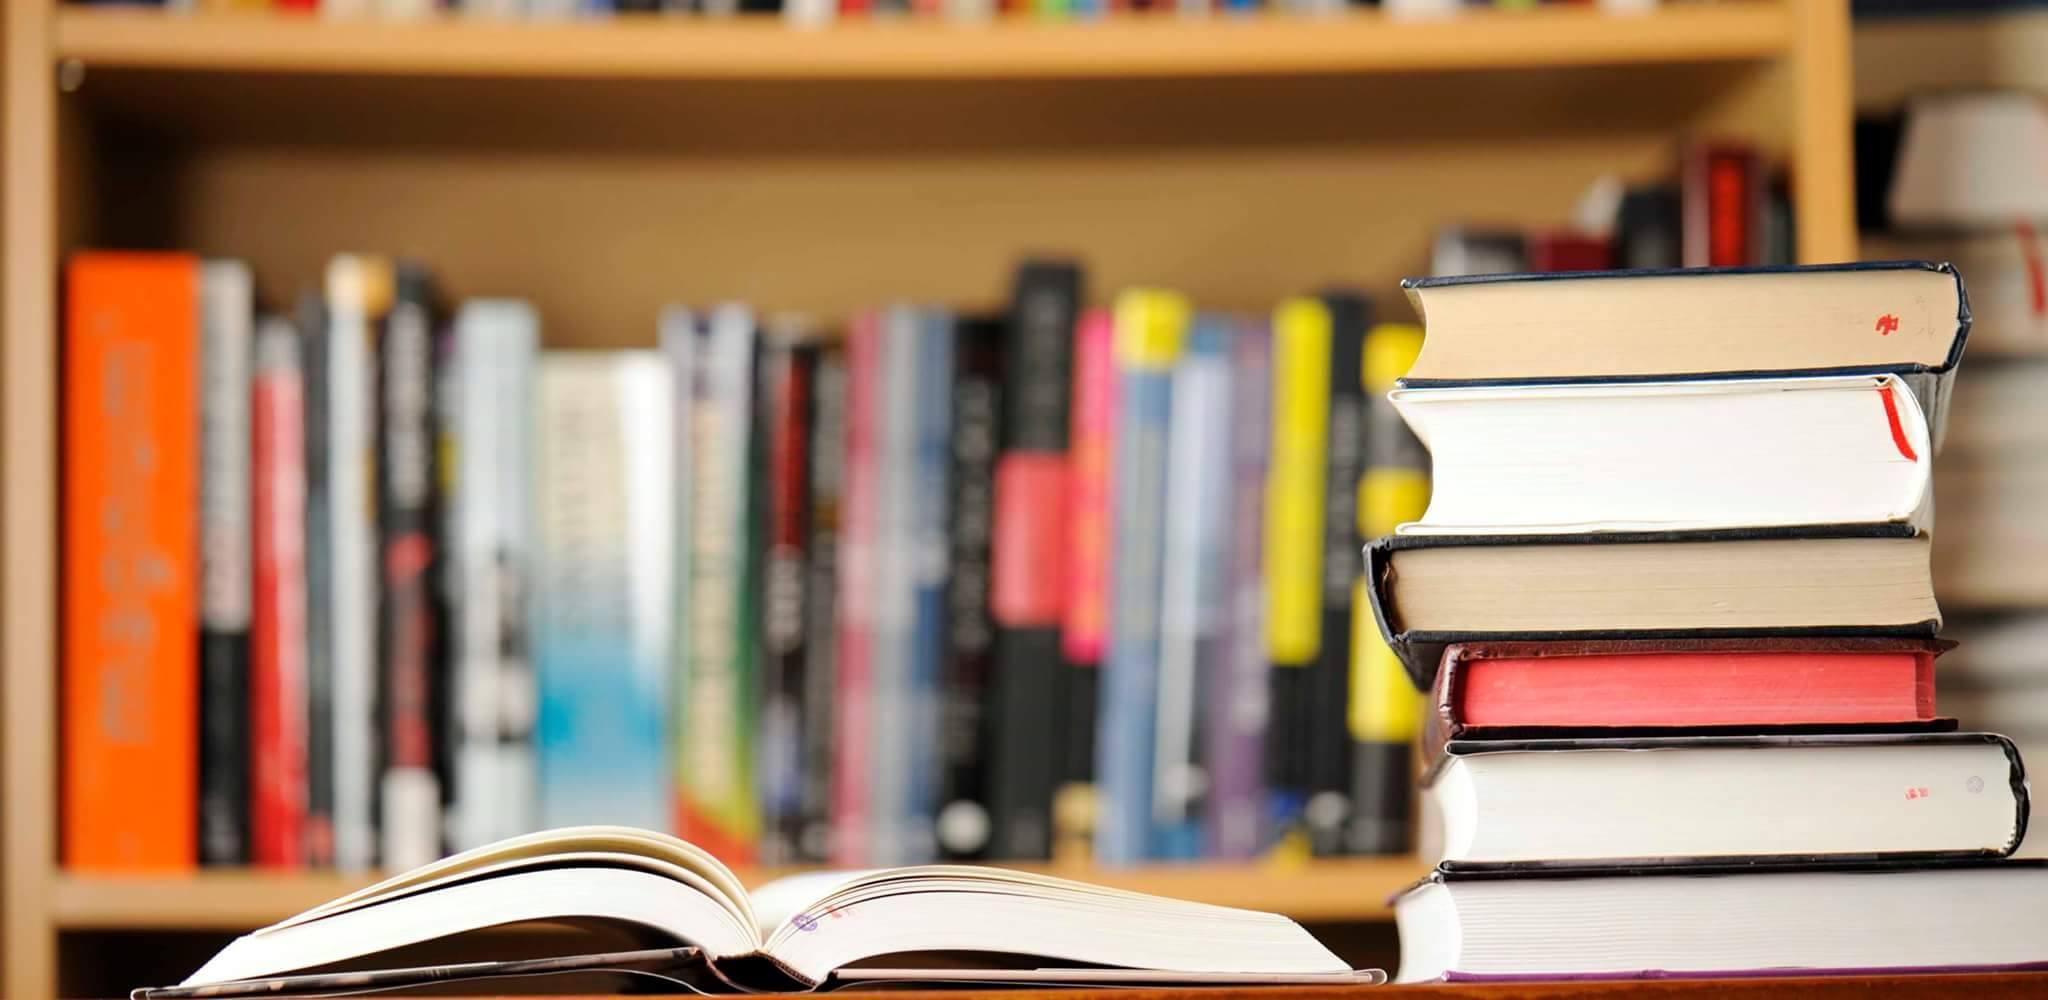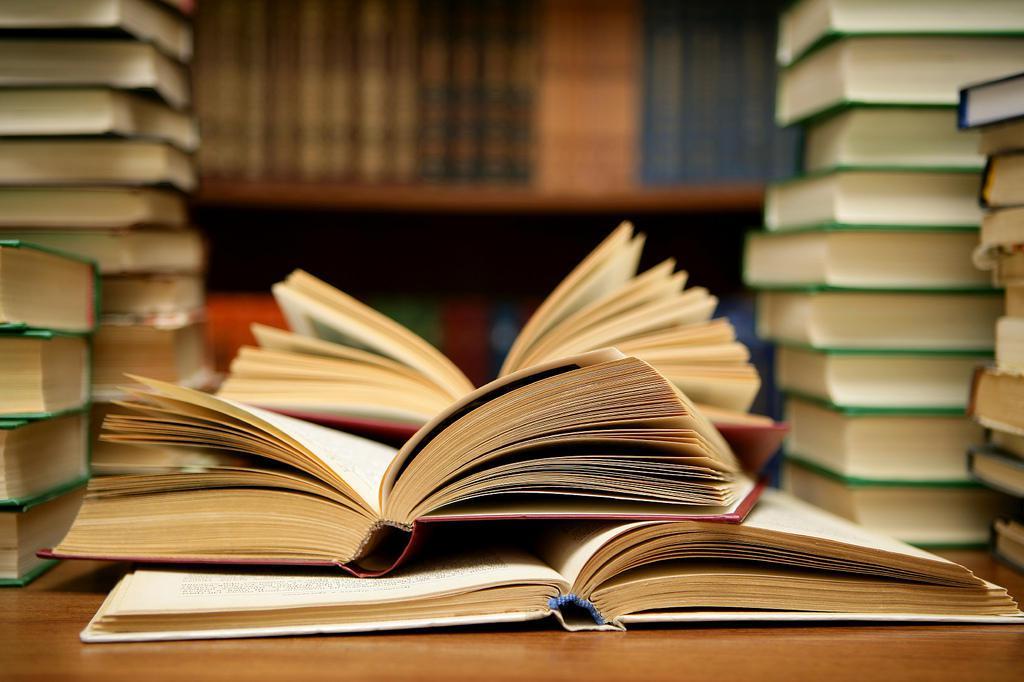The first image is the image on the left, the second image is the image on the right. Evaluate the accuracy of this statement regarding the images: "there are open books laying next to a stack of 6 books next to it". Is it true? Answer yes or no. Yes. The first image is the image on the left, the second image is the image on the right. Considering the images on both sides, is "The right image shows at least one book withe its pages splayed open." valid? Answer yes or no. Yes. 